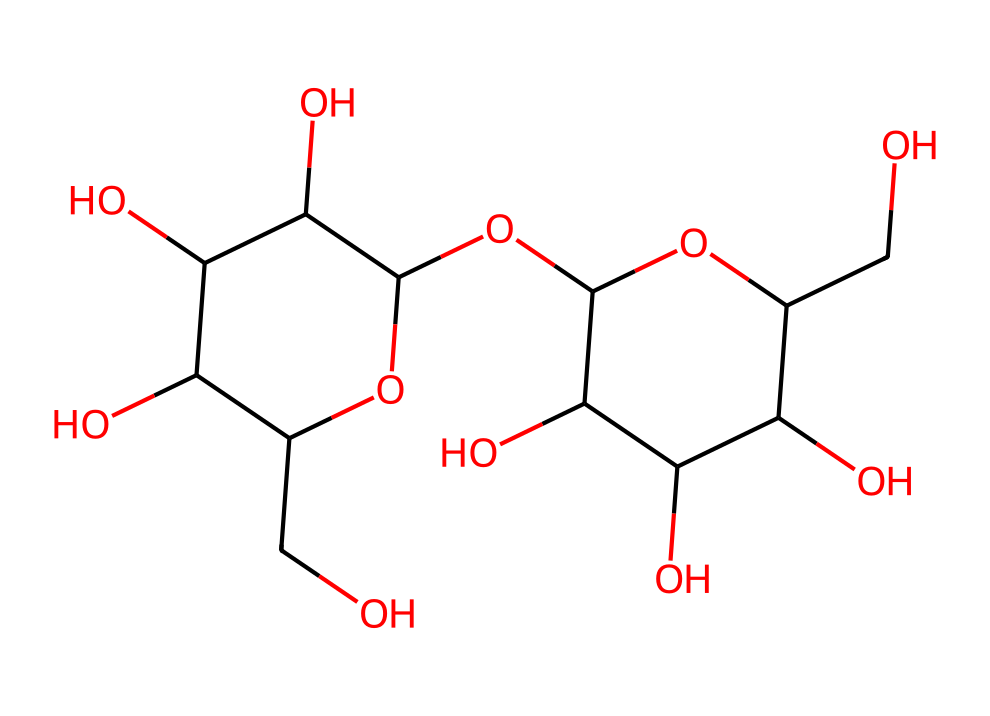What is the molecular formula of lactose? From the structural information provided in the SMILES representation, we can deduce the molecular formula by counting the carbon (C), hydrogen (H), and oxygen (O) atoms. In this structure, there are 12 carbon atoms, 22 hydrogen atoms, and 11 oxygen atoms.
Answer: C12H22O11 How many rings are present in the structure of lactose? By examining the structure represented in the SMILES notation, two cyclic structures are observed, which are indicative of the two ring forms in the molecule.
Answer: 2 What type of carbohydrate is lactose classified as? Lactose consists of two monosaccharides, glucose and galactose, linked together. Therefore, it is classified as a disaccharide.
Answer: disaccharide What functional groups are present in lactose? Analyzing the SMILES representation, we identify hydroxyl (-OH) groups that define lactose's characteristics as a sugar. These functional groups contribute to its solubility and sweetness.
Answer: hydroxyl groups What is the primary source of lactose in the diet? Lactose is predominantly found in dairy products, as it is the primary sugar present in milk and other milk-derived products.
Answer: dairy products How does the structure of lactose affect its sweetness? The arrangement of the hydroxyl groups and the specific bond configuration within the structure influences how lactose interacts with taste receptors on the tongue, contributing to its sweetness perception.
Answer: molecular arrangement 